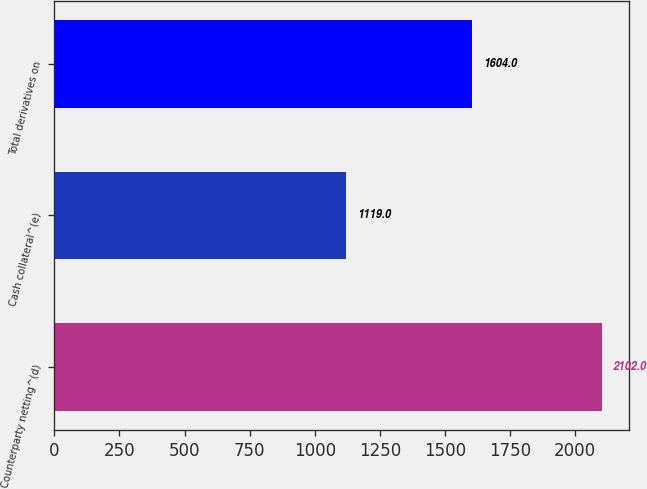<chart> <loc_0><loc_0><loc_500><loc_500><bar_chart><fcel>Counterparty netting^(d)<fcel>Cash collateral^(e)<fcel>Total derivatives on<nl><fcel>2102<fcel>1119<fcel>1604<nl></chart> 